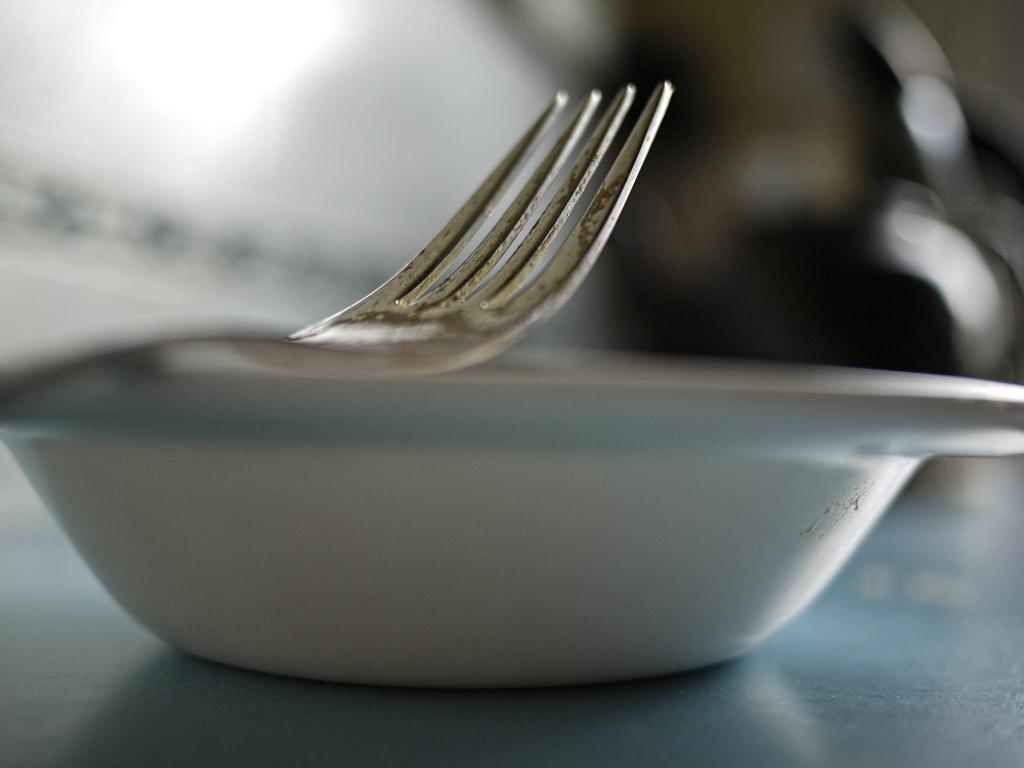What piece of furniture is present in the image? There is a table in the image. What is on top of the table? There is a bowl on the table. What utensil can be seen inside the bowl? There is a fork in the bowl. How many letters are being written by the boys with the bears in the image? There are no boys or bears present in the image; it only features a table, a bowl, and a fork. 